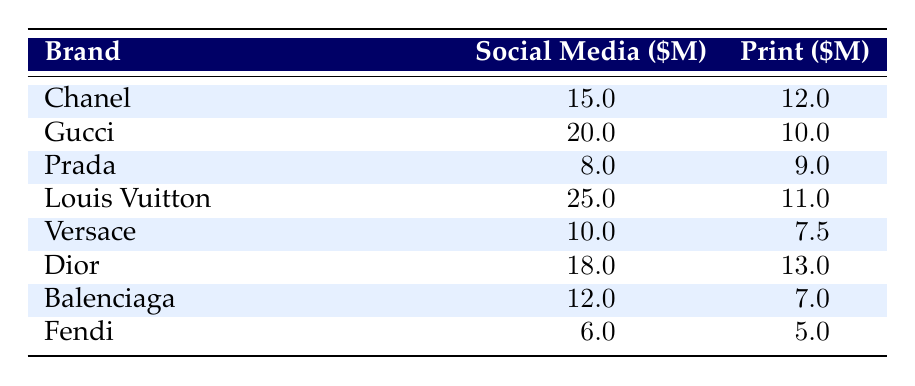What is the highest amount spent on social media by any brand? From the table, we can see that Louis Vuitton spent the most on social media with a total of 25 million dollars.
Answer: 25 million dollars Which brand spent the least on print advertisements? By examining the print spending values in the table, we find that Fendi spent the least at 5 million dollars.
Answer: 5 million dollars What is the total social media spending for all brands listed? Adding the social media spending: 15 + 20 + 8 + 25 + 10 + 18 + 12 + 6 = 114 million dollars.
Answer: 114 million dollars Did any brand spend more on print than on social media? Looking at each brand's spending, we can see that Prada (9 million on print vs. 8 million on social media) and Fendi (5 million on print vs. 6 million on social media) spent more on print.
Answer: Yes Which brand had the biggest difference between social media and print spending? We can calculate the differences: Chanel (3M), Gucci (10M), Prada (1M), Louis Vuitton (14M), Versace (2.5M), Dior (5M), Balenciaga (5M), Fendi (1M). The largest difference is for Louis Vuitton at 14 million dollars.
Answer: 14 million dollars On average, how much did brands spend on print advertisements? We add the print spending values: 12 + 10 + 9 + 11 + 7.5 + 13 + 7 + 5 = 84.5 million dollars and divide by the number of brands (8) to get an average of 10.56 million dollars.
Answer: 10.56 million dollars Which brand has the highest ratio of social media to print spending? For each brand, calculate the ratio: Chanel (15/12 = 1.25), Gucci (20/10 = 2), Prada (8/9 ≈ 0.89), Louis Vuitton (25/11 ≈ 2.27), Versace (10/7.5 ≈ 1.33), Dior (18/13 ≈ 1.38), Balenciaga (12/7 ≈ 1.71), Fendi (6/5 = 1.2). The highest ratio is Louis Vuitton at approximately 2.27.
Answer: Louis Vuitton What is the total spending on print advertisements by the top three brands? Adding the print spending of the top three brands (Louis Vuitton, Gucci, Chanel): 11 + 10 + 12 = 33 million dollars.
Answer: 33 million dollars Is the combined spending on social media by Chanel and Dior greater than that of Gucci? Chanel and Dior's combined spending is 15 + 18 = 33 million dollars, while Gucci spent 20 million. Since 33 is greater than 20, the answer is yes.
Answer: Yes What percentage of total advertising spending did social media represent for Balenciaga? Balenciaga's total spending is 12 + 7 = 19 million dollars. Social media makes up (12/19) * 100 ≈ 63.16%.
Answer: Approximately 63.16% 